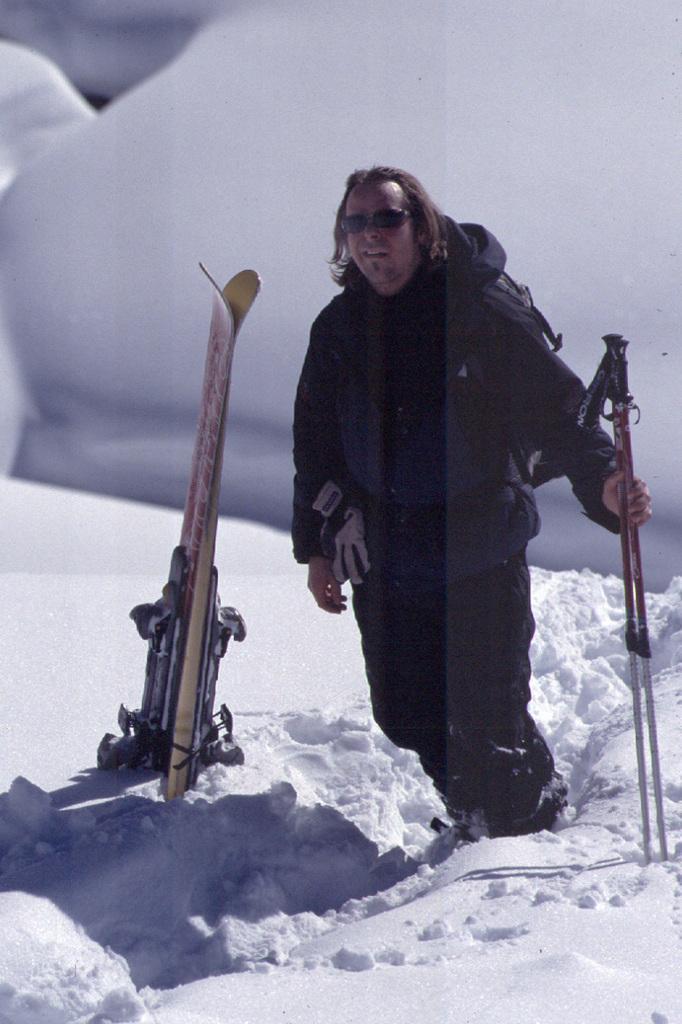Can you describe this image briefly? A person wearing a black jacket and black dress is wearing a goggles. And he is holding a sticks and he is standing over the snow. Behind him snow are there. And also ski boards are there. 